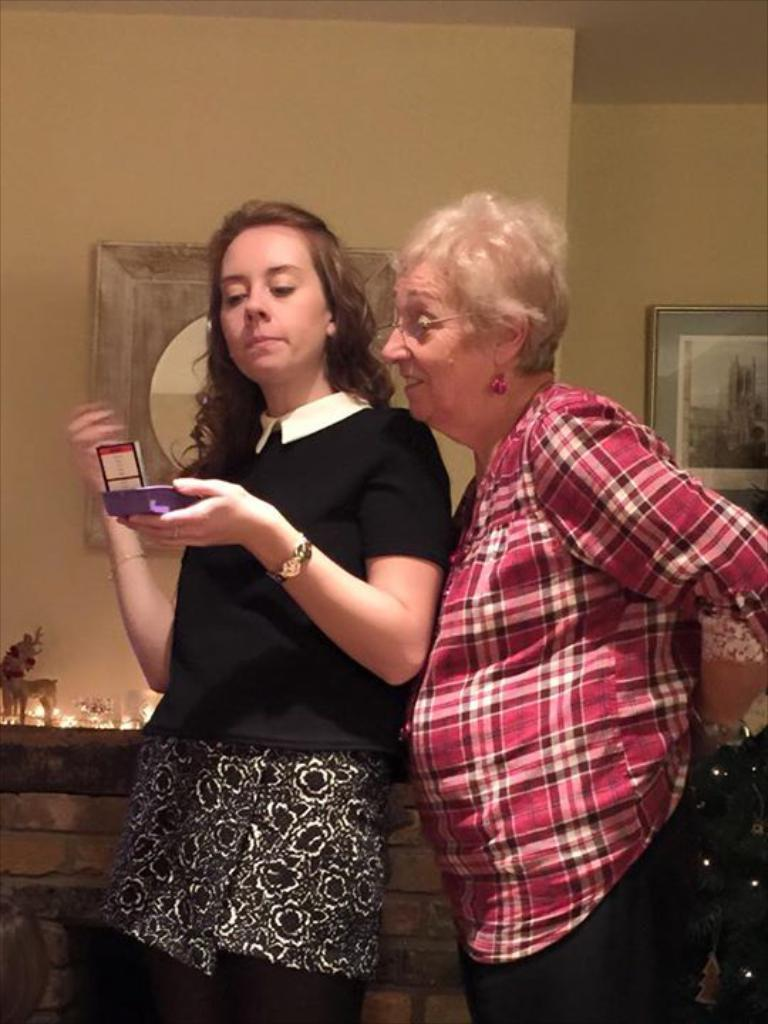How many women are present in the image? There are two women in the image. What is one of the women doing with her hand? One of the women is holding an object in her hand. What can be seen in the background of the image? There are lights, toys, and frames on the wall visible in the background of the image. What type of ring can be seen on the head of one of the women in the image? There is no ring visible on the head of either woman in the image. 